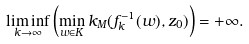Convert formula to latex. <formula><loc_0><loc_0><loc_500><loc_500>\liminf _ { k \rightarrow \infty } \left ( \min _ { w \in K } k _ { M } ( f ^ { - 1 } _ { k } ( w ) , z _ { 0 } ) \right ) = + \infty .</formula> 